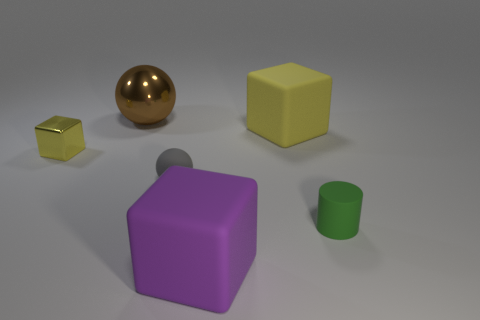Add 4 large metal balls. How many objects exist? 10 Subtract all spheres. How many objects are left? 4 Add 2 gray balls. How many gray balls are left? 3 Add 6 gray matte objects. How many gray matte objects exist? 7 Subtract 0 green spheres. How many objects are left? 6 Subtract all big blue cylinders. Subtract all tiny yellow things. How many objects are left? 5 